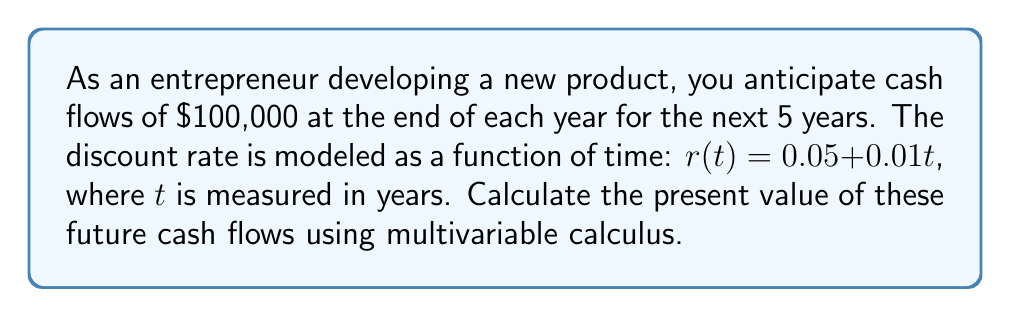Help me with this question. To solve this problem, we'll use the continuous-time present value formula and integrate over the 5-year period:

1) The general formula for present value in continuous time is:

   $$PV = \int_0^T C(t)e^{-\int_0^t r(s)ds}dt$$

   where $C(t)$ is the cash flow at time $t$, and $r(s)$ is the discount rate function.

2) In our case, $C(t) = 100,000$ (constant for all $t$), and $r(t) = 0.05 + 0.01t$

3) First, let's calculate the inner integral $\int_0^t r(s)ds$:

   $$\int_0^t (0.05 + 0.01s)ds = [0.05s + 0.005s^2]_0^t = 0.05t + 0.005t^2$$

4) Now, we can set up our main integral:

   $$PV = \int_0^5 100,000e^{-(0.05t + 0.005t^2)}dt$$

5) This integral doesn't have an elementary antiderivative, so we need to use numerical integration. Using a computer algebra system or numerical integration tool, we can evaluate this integral:

   $$PV \approx 432,948.53$$

Thus, the present value of the future cash flows is approximately $432,948.53.
Answer: $432,948.53 